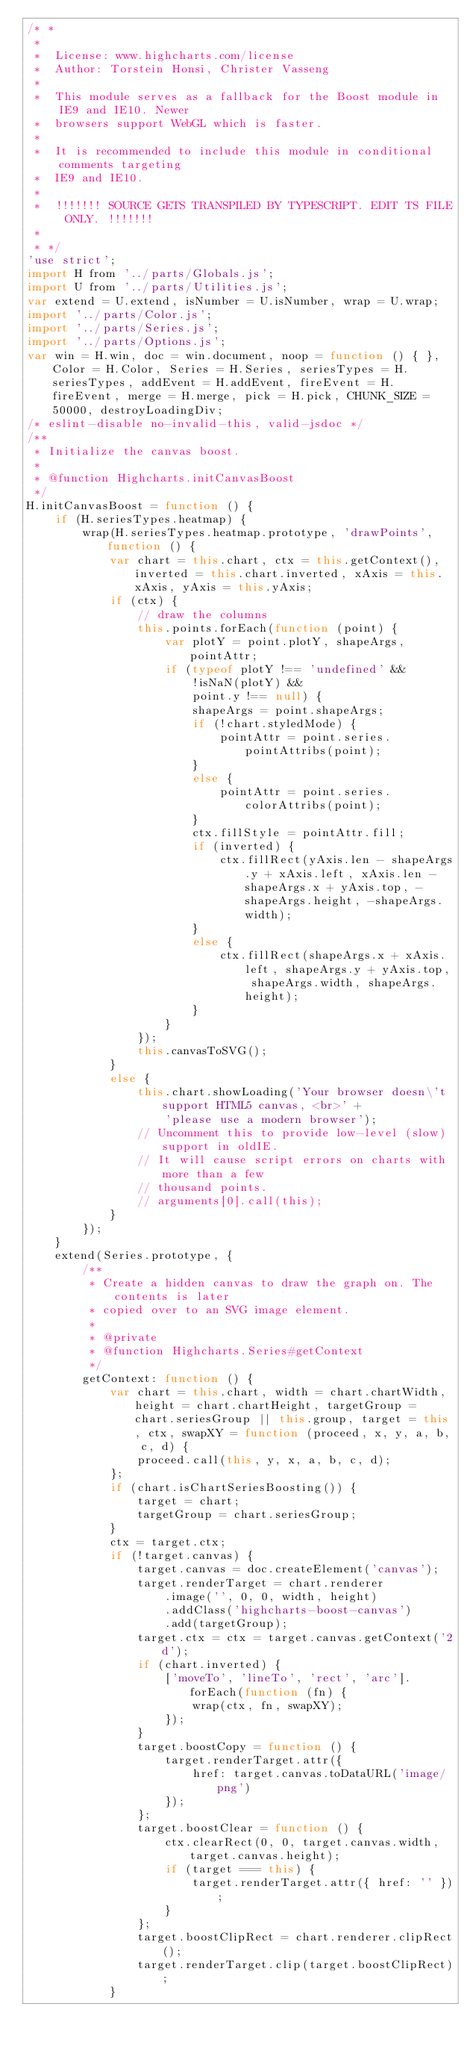<code> <loc_0><loc_0><loc_500><loc_500><_JavaScript_>/* *
 *
 *  License: www.highcharts.com/license
 *  Author: Torstein Honsi, Christer Vasseng
 *
 *  This module serves as a fallback for the Boost module in IE9 and IE10. Newer
 *  browsers support WebGL which is faster.
 *
 *  It is recommended to include this module in conditional comments targeting
 *  IE9 and IE10.
 *
 *  !!!!!!! SOURCE GETS TRANSPILED BY TYPESCRIPT. EDIT TS FILE ONLY. !!!!!!!
 *
 * */
'use strict';
import H from '../parts/Globals.js';
import U from '../parts/Utilities.js';
var extend = U.extend, isNumber = U.isNumber, wrap = U.wrap;
import '../parts/Color.js';
import '../parts/Series.js';
import '../parts/Options.js';
var win = H.win, doc = win.document, noop = function () { }, Color = H.Color, Series = H.Series, seriesTypes = H.seriesTypes, addEvent = H.addEvent, fireEvent = H.fireEvent, merge = H.merge, pick = H.pick, CHUNK_SIZE = 50000, destroyLoadingDiv;
/* eslint-disable no-invalid-this, valid-jsdoc */
/**
 * Initialize the canvas boost.
 *
 * @function Highcharts.initCanvasBoost
 */
H.initCanvasBoost = function () {
    if (H.seriesTypes.heatmap) {
        wrap(H.seriesTypes.heatmap.prototype, 'drawPoints', function () {
            var chart = this.chart, ctx = this.getContext(), inverted = this.chart.inverted, xAxis = this.xAxis, yAxis = this.yAxis;
            if (ctx) {
                // draw the columns
                this.points.forEach(function (point) {
                    var plotY = point.plotY, shapeArgs, pointAttr;
                    if (typeof plotY !== 'undefined' &&
                        !isNaN(plotY) &&
                        point.y !== null) {
                        shapeArgs = point.shapeArgs;
                        if (!chart.styledMode) {
                            pointAttr = point.series.pointAttribs(point);
                        }
                        else {
                            pointAttr = point.series.colorAttribs(point);
                        }
                        ctx.fillStyle = pointAttr.fill;
                        if (inverted) {
                            ctx.fillRect(yAxis.len - shapeArgs.y + xAxis.left, xAxis.len - shapeArgs.x + yAxis.top, -shapeArgs.height, -shapeArgs.width);
                        }
                        else {
                            ctx.fillRect(shapeArgs.x + xAxis.left, shapeArgs.y + yAxis.top, shapeArgs.width, shapeArgs.height);
                        }
                    }
                });
                this.canvasToSVG();
            }
            else {
                this.chart.showLoading('Your browser doesn\'t support HTML5 canvas, <br>' +
                    'please use a modern browser');
                // Uncomment this to provide low-level (slow) support in oldIE.
                // It will cause script errors on charts with more than a few
                // thousand points.
                // arguments[0].call(this);
            }
        });
    }
    extend(Series.prototype, {
        /**
         * Create a hidden canvas to draw the graph on. The contents is later
         * copied over to an SVG image element.
         *
         * @private
         * @function Highcharts.Series#getContext
         */
        getContext: function () {
            var chart = this.chart, width = chart.chartWidth, height = chart.chartHeight, targetGroup = chart.seriesGroup || this.group, target = this, ctx, swapXY = function (proceed, x, y, a, b, c, d) {
                proceed.call(this, y, x, a, b, c, d);
            };
            if (chart.isChartSeriesBoosting()) {
                target = chart;
                targetGroup = chart.seriesGroup;
            }
            ctx = target.ctx;
            if (!target.canvas) {
                target.canvas = doc.createElement('canvas');
                target.renderTarget = chart.renderer
                    .image('', 0, 0, width, height)
                    .addClass('highcharts-boost-canvas')
                    .add(targetGroup);
                target.ctx = ctx = target.canvas.getContext('2d');
                if (chart.inverted) {
                    ['moveTo', 'lineTo', 'rect', 'arc'].forEach(function (fn) {
                        wrap(ctx, fn, swapXY);
                    });
                }
                target.boostCopy = function () {
                    target.renderTarget.attr({
                        href: target.canvas.toDataURL('image/png')
                    });
                };
                target.boostClear = function () {
                    ctx.clearRect(0, 0, target.canvas.width, target.canvas.height);
                    if (target === this) {
                        target.renderTarget.attr({ href: '' });
                    }
                };
                target.boostClipRect = chart.renderer.clipRect();
                target.renderTarget.clip(target.boostClipRect);
            }</code> 